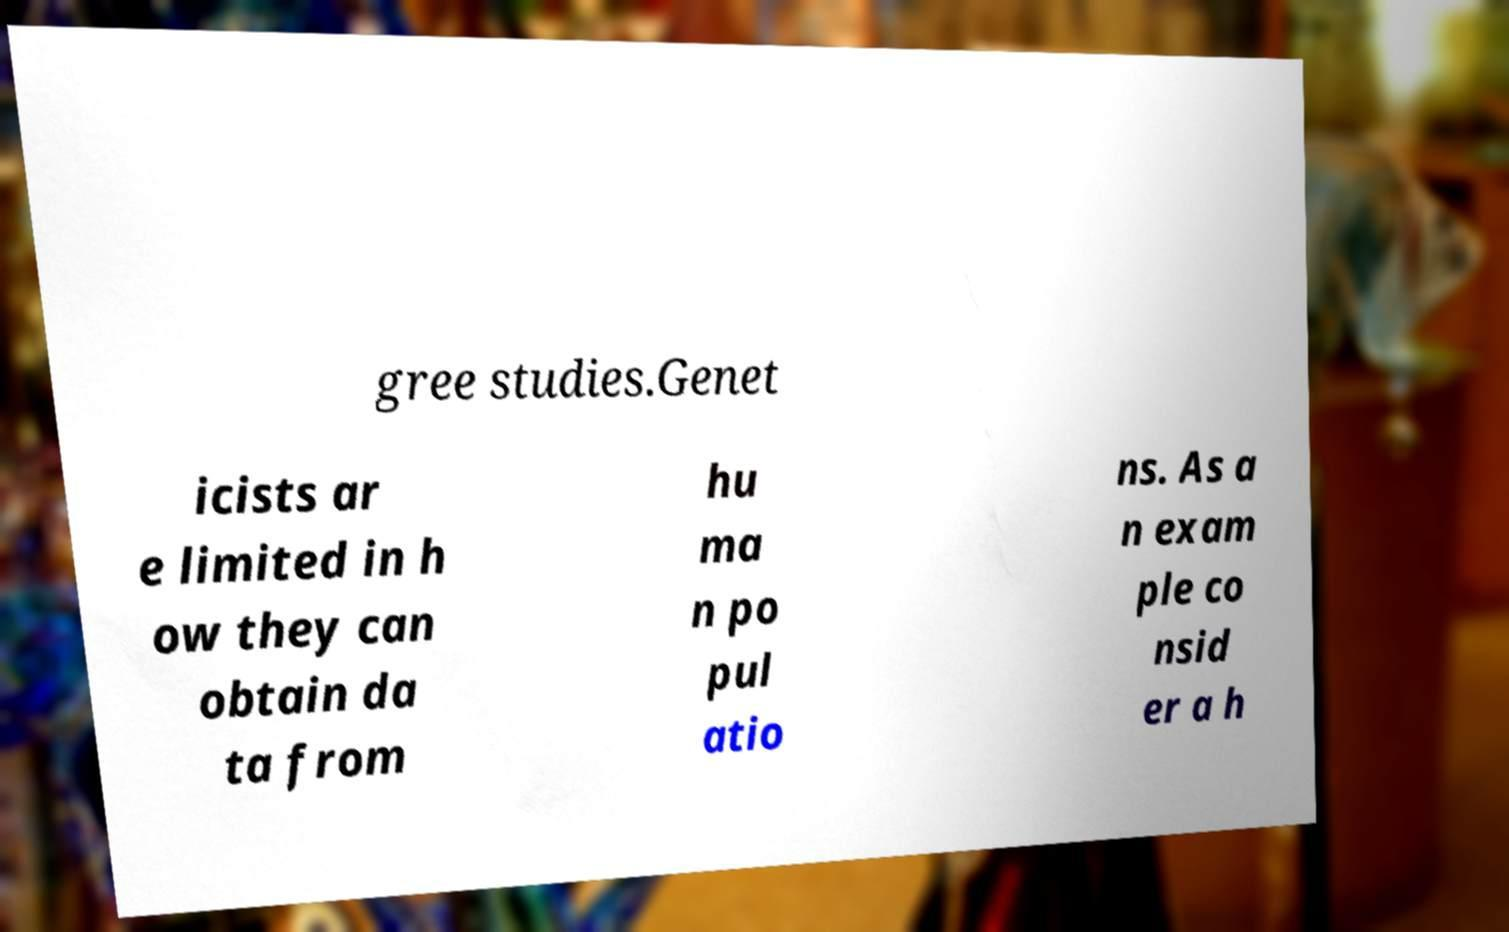Can you accurately transcribe the text from the provided image for me? gree studies.Genet icists ar e limited in h ow they can obtain da ta from hu ma n po pul atio ns. As a n exam ple co nsid er a h 